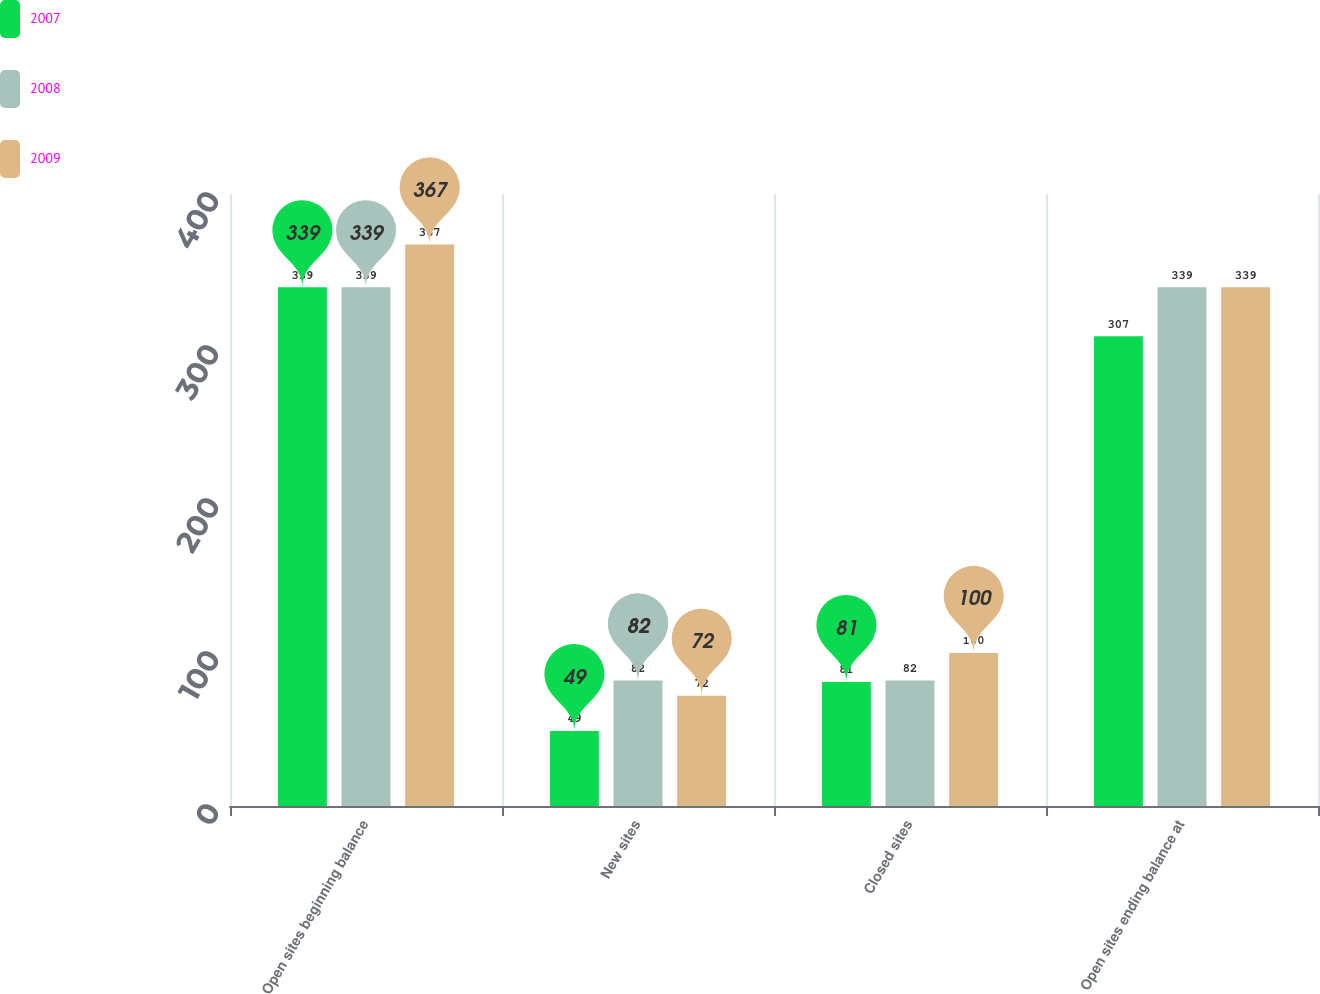Convert chart. <chart><loc_0><loc_0><loc_500><loc_500><stacked_bar_chart><ecel><fcel>Open sites beginning balance<fcel>New sites<fcel>Closed sites<fcel>Open sites ending balance at<nl><fcel>2007<fcel>339<fcel>49<fcel>81<fcel>307<nl><fcel>2008<fcel>339<fcel>82<fcel>82<fcel>339<nl><fcel>2009<fcel>367<fcel>72<fcel>100<fcel>339<nl></chart> 